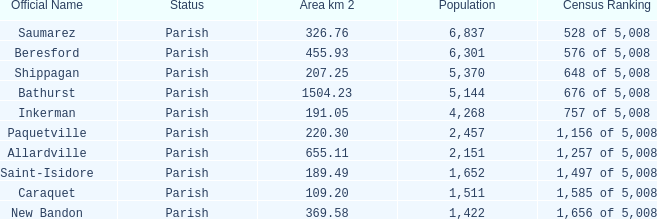What is the Area of the Saint-Isidore Parish with a Population smaller than 4,268? 189.49. 